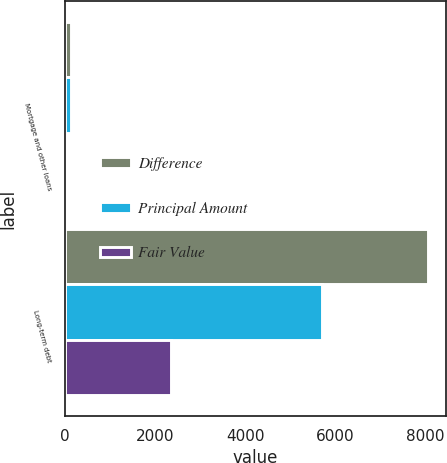Convert chart. <chart><loc_0><loc_0><loc_500><loc_500><stacked_bar_chart><ecel><fcel>Mortgage and other loans<fcel>Long-term debt<nl><fcel>Difference<fcel>134<fcel>8055<nl><fcel>Principal Amount<fcel>141<fcel>5705<nl><fcel>Fair Value<fcel>7<fcel>2350<nl></chart> 